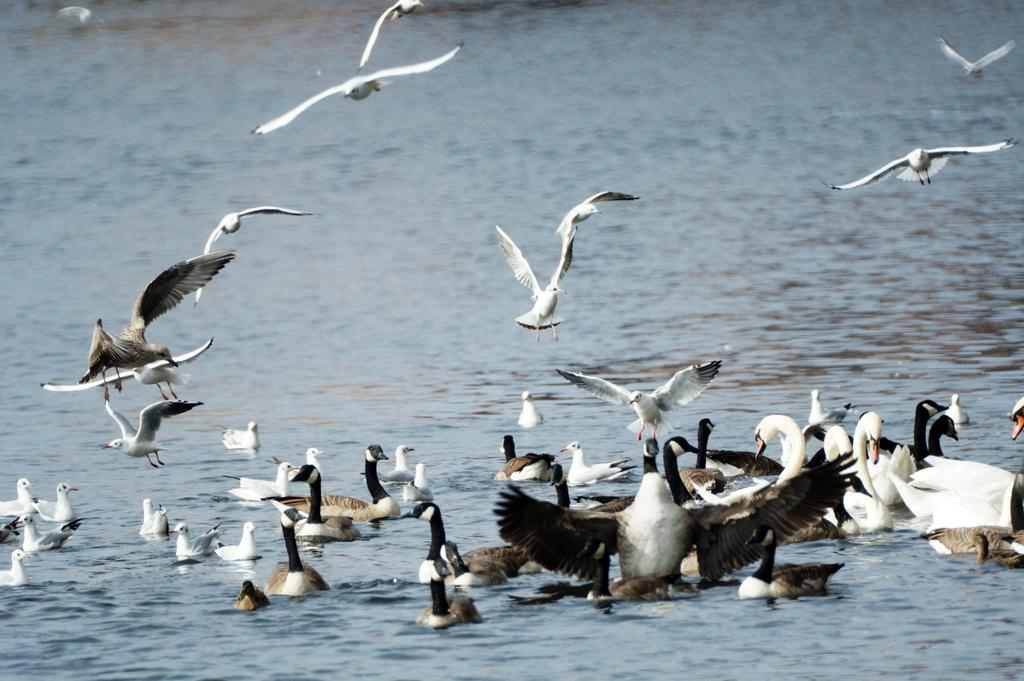What is the primary element in the image? The image consists of water. What types of birds are present in the water? There are swans and ducks in the water. Are any of the birds in the image flying? Yes, some swans and ducks are flying. What type of net can be seen in the image? There is no net present in the image; it consists of water with swans and ducks. 